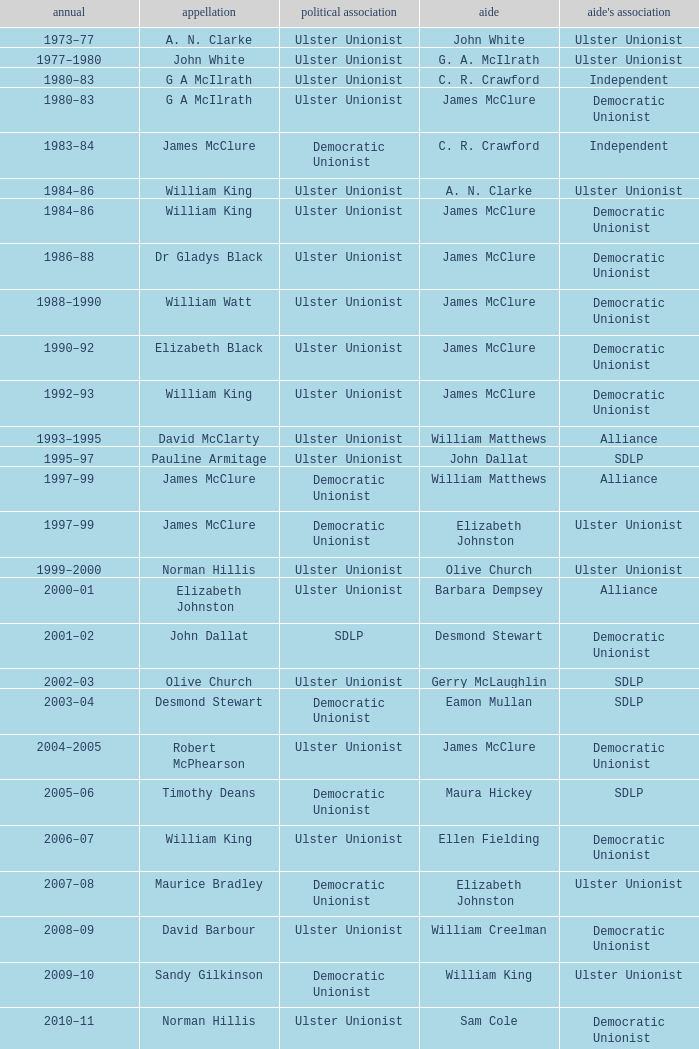What is the name of the Deputy when the Name was elizabeth black? James McClure. 